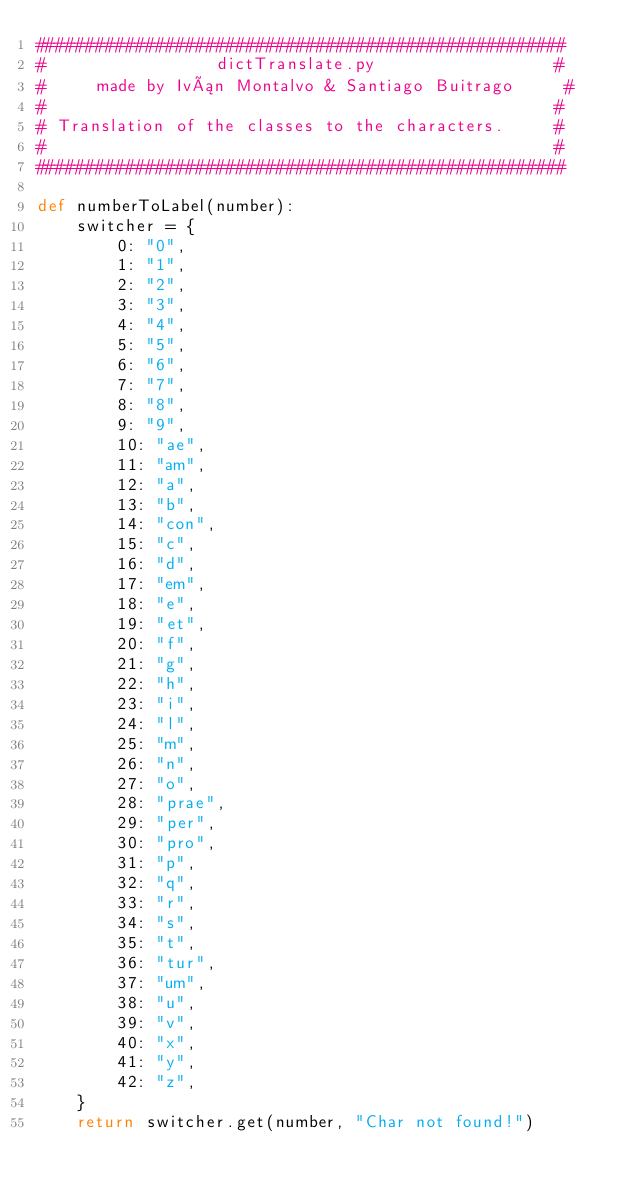<code> <loc_0><loc_0><loc_500><loc_500><_Python_>#####################################################
#                 dictTranslate.py                  #
#     made by Iván Montalvo & Santiago Buitrago     #
#                                                   #
# Translation of the classes to the characters.     #
#                                                   #
#####################################################

def numberToLabel(number):
    switcher = {
        0: "0",
        1: "1",
        2: "2",
        3: "3",
        4: "4",
        5: "5",
        6: "6",
        7: "7",
        8: "8",
        9: "9",
        10: "ae",
        11: "am",
        12: "a",
        13: "b",
        14: "con",
        15: "c",
        16: "d",
        17: "em",
        18: "e",
        19: "et",
        20: "f",
        21: "g",
        22: "h",
        23: "i",
        24: "l",
        25: "m",
        26: "n",
        27: "o",
        28: "prae",
        29: "per",
        30: "pro",
        31: "p",
        32: "q",
        33: "r",
        34: "s",
        35: "t",
        36: "tur",
        37: "um",
        38: "u",
        39: "v",
        40: "x",
        41: "y",
        42: "z",
    }
    return switcher.get(number, "Char not found!")
</code> 